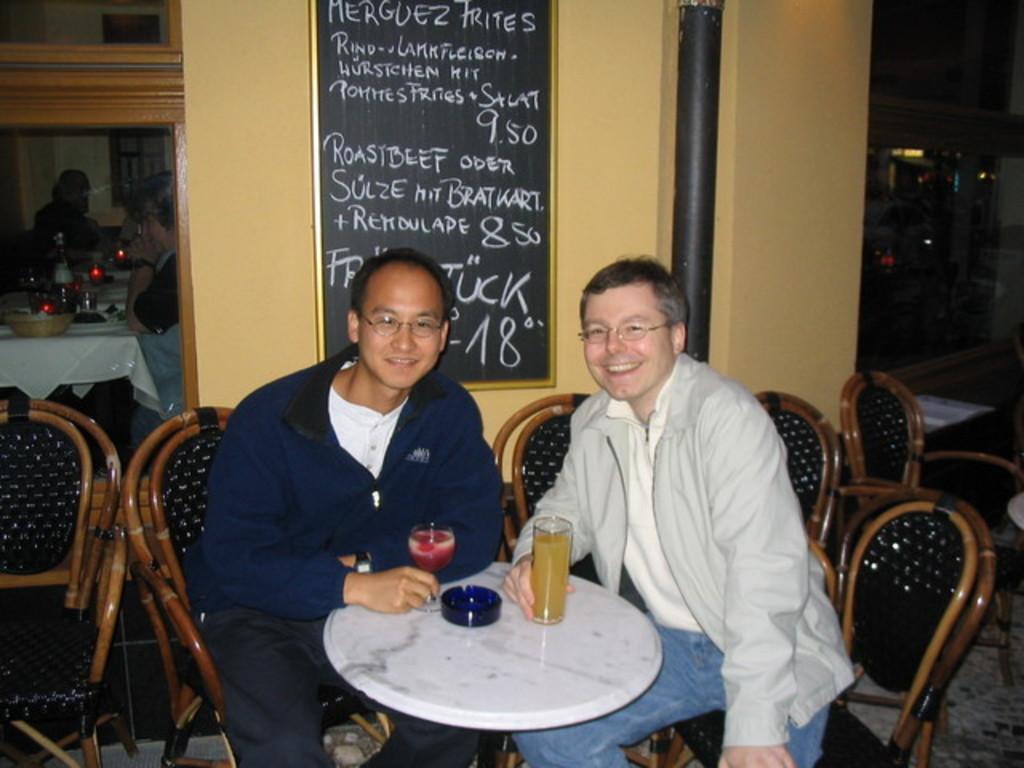Describe this image in one or two sentences. As we can see in the image, there is a black color door, wall, two people sitting on chairs and in the front there is a table. On table there are glasses 